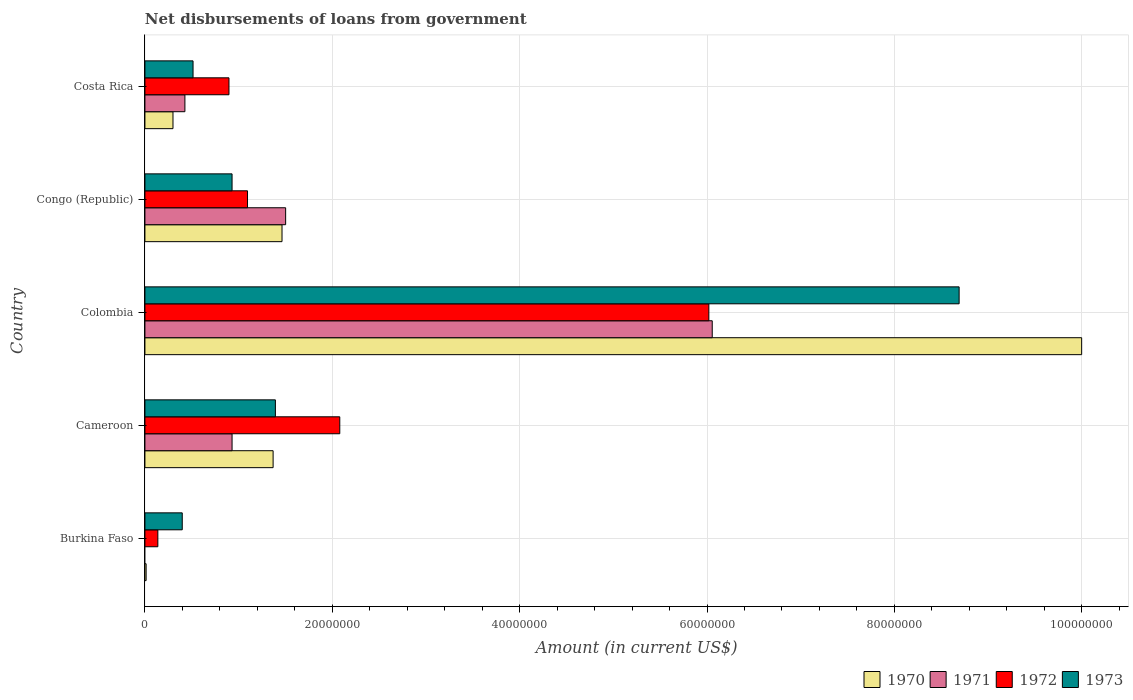How many different coloured bars are there?
Provide a short and direct response. 4. How many groups of bars are there?
Your response must be concise. 5. How many bars are there on the 1st tick from the top?
Your response must be concise. 4. How many bars are there on the 2nd tick from the bottom?
Offer a terse response. 4. In how many cases, is the number of bars for a given country not equal to the number of legend labels?
Offer a terse response. 1. What is the amount of loan disbursed from government in 1972 in Congo (Republic)?
Provide a short and direct response. 1.10e+07. Across all countries, what is the maximum amount of loan disbursed from government in 1973?
Offer a terse response. 8.69e+07. Across all countries, what is the minimum amount of loan disbursed from government in 1973?
Your answer should be very brief. 3.98e+06. In which country was the amount of loan disbursed from government in 1970 maximum?
Offer a terse response. Colombia. What is the total amount of loan disbursed from government in 1973 in the graph?
Your response must be concise. 1.19e+08. What is the difference between the amount of loan disbursed from government in 1973 in Cameroon and that in Costa Rica?
Your answer should be very brief. 8.79e+06. What is the difference between the amount of loan disbursed from government in 1972 in Congo (Republic) and the amount of loan disbursed from government in 1970 in Costa Rica?
Your answer should be compact. 7.96e+06. What is the average amount of loan disbursed from government in 1973 per country?
Your answer should be very brief. 2.39e+07. What is the difference between the amount of loan disbursed from government in 1973 and amount of loan disbursed from government in 1971 in Cameroon?
Your answer should be very brief. 4.63e+06. What is the ratio of the amount of loan disbursed from government in 1973 in Cameroon to that in Costa Rica?
Your response must be concise. 2.71. Is the amount of loan disbursed from government in 1972 in Burkina Faso less than that in Congo (Republic)?
Provide a succinct answer. Yes. Is the difference between the amount of loan disbursed from government in 1973 in Colombia and Congo (Republic) greater than the difference between the amount of loan disbursed from government in 1971 in Colombia and Congo (Republic)?
Your answer should be very brief. Yes. What is the difference between the highest and the second highest amount of loan disbursed from government in 1973?
Offer a terse response. 7.30e+07. What is the difference between the highest and the lowest amount of loan disbursed from government in 1972?
Your response must be concise. 5.88e+07. Is it the case that in every country, the sum of the amount of loan disbursed from government in 1970 and amount of loan disbursed from government in 1971 is greater than the sum of amount of loan disbursed from government in 1972 and amount of loan disbursed from government in 1973?
Provide a succinct answer. No. Is it the case that in every country, the sum of the amount of loan disbursed from government in 1972 and amount of loan disbursed from government in 1970 is greater than the amount of loan disbursed from government in 1971?
Provide a succinct answer. Yes. Are all the bars in the graph horizontal?
Your answer should be compact. Yes. How many countries are there in the graph?
Offer a very short reply. 5. Are the values on the major ticks of X-axis written in scientific E-notation?
Ensure brevity in your answer.  No. Does the graph contain any zero values?
Keep it short and to the point. Yes. How many legend labels are there?
Ensure brevity in your answer.  4. How are the legend labels stacked?
Provide a short and direct response. Horizontal. What is the title of the graph?
Your response must be concise. Net disbursements of loans from government. What is the label or title of the Y-axis?
Provide a short and direct response. Country. What is the Amount (in current US$) of 1970 in Burkina Faso?
Give a very brief answer. 1.29e+05. What is the Amount (in current US$) in 1972 in Burkina Faso?
Keep it short and to the point. 1.38e+06. What is the Amount (in current US$) of 1973 in Burkina Faso?
Your answer should be compact. 3.98e+06. What is the Amount (in current US$) of 1970 in Cameroon?
Provide a short and direct response. 1.37e+07. What is the Amount (in current US$) in 1971 in Cameroon?
Offer a very short reply. 9.30e+06. What is the Amount (in current US$) of 1972 in Cameroon?
Keep it short and to the point. 2.08e+07. What is the Amount (in current US$) of 1973 in Cameroon?
Provide a succinct answer. 1.39e+07. What is the Amount (in current US$) in 1970 in Colombia?
Give a very brief answer. 1.00e+08. What is the Amount (in current US$) in 1971 in Colombia?
Your answer should be very brief. 6.06e+07. What is the Amount (in current US$) of 1972 in Colombia?
Your answer should be very brief. 6.02e+07. What is the Amount (in current US$) of 1973 in Colombia?
Give a very brief answer. 8.69e+07. What is the Amount (in current US$) of 1970 in Congo (Republic)?
Give a very brief answer. 1.46e+07. What is the Amount (in current US$) of 1971 in Congo (Republic)?
Your answer should be very brief. 1.50e+07. What is the Amount (in current US$) in 1972 in Congo (Republic)?
Provide a short and direct response. 1.10e+07. What is the Amount (in current US$) in 1973 in Congo (Republic)?
Offer a very short reply. 9.30e+06. What is the Amount (in current US$) of 1970 in Costa Rica?
Ensure brevity in your answer.  3.00e+06. What is the Amount (in current US$) of 1971 in Costa Rica?
Offer a very short reply. 4.27e+06. What is the Amount (in current US$) of 1972 in Costa Rica?
Your response must be concise. 8.97e+06. What is the Amount (in current US$) in 1973 in Costa Rica?
Make the answer very short. 5.14e+06. Across all countries, what is the maximum Amount (in current US$) in 1970?
Ensure brevity in your answer.  1.00e+08. Across all countries, what is the maximum Amount (in current US$) of 1971?
Keep it short and to the point. 6.06e+07. Across all countries, what is the maximum Amount (in current US$) in 1972?
Provide a short and direct response. 6.02e+07. Across all countries, what is the maximum Amount (in current US$) in 1973?
Provide a short and direct response. 8.69e+07. Across all countries, what is the minimum Amount (in current US$) of 1970?
Offer a very short reply. 1.29e+05. Across all countries, what is the minimum Amount (in current US$) in 1971?
Ensure brevity in your answer.  0. Across all countries, what is the minimum Amount (in current US$) in 1972?
Make the answer very short. 1.38e+06. Across all countries, what is the minimum Amount (in current US$) of 1973?
Provide a short and direct response. 3.98e+06. What is the total Amount (in current US$) in 1970 in the graph?
Your response must be concise. 1.31e+08. What is the total Amount (in current US$) in 1971 in the graph?
Your response must be concise. 8.92e+07. What is the total Amount (in current US$) in 1972 in the graph?
Your response must be concise. 1.02e+08. What is the total Amount (in current US$) of 1973 in the graph?
Your response must be concise. 1.19e+08. What is the difference between the Amount (in current US$) of 1970 in Burkina Faso and that in Cameroon?
Your response must be concise. -1.36e+07. What is the difference between the Amount (in current US$) in 1972 in Burkina Faso and that in Cameroon?
Provide a short and direct response. -1.94e+07. What is the difference between the Amount (in current US$) in 1973 in Burkina Faso and that in Cameroon?
Provide a short and direct response. -9.94e+06. What is the difference between the Amount (in current US$) in 1970 in Burkina Faso and that in Colombia?
Offer a terse response. -9.99e+07. What is the difference between the Amount (in current US$) of 1972 in Burkina Faso and that in Colombia?
Keep it short and to the point. -5.88e+07. What is the difference between the Amount (in current US$) in 1973 in Burkina Faso and that in Colombia?
Offer a very short reply. -8.29e+07. What is the difference between the Amount (in current US$) in 1970 in Burkina Faso and that in Congo (Republic)?
Keep it short and to the point. -1.45e+07. What is the difference between the Amount (in current US$) in 1972 in Burkina Faso and that in Congo (Republic)?
Keep it short and to the point. -9.57e+06. What is the difference between the Amount (in current US$) of 1973 in Burkina Faso and that in Congo (Republic)?
Provide a succinct answer. -5.32e+06. What is the difference between the Amount (in current US$) of 1970 in Burkina Faso and that in Costa Rica?
Ensure brevity in your answer.  -2.87e+06. What is the difference between the Amount (in current US$) of 1972 in Burkina Faso and that in Costa Rica?
Your response must be concise. -7.59e+06. What is the difference between the Amount (in current US$) in 1973 in Burkina Faso and that in Costa Rica?
Offer a terse response. -1.15e+06. What is the difference between the Amount (in current US$) of 1970 in Cameroon and that in Colombia?
Your answer should be compact. -8.63e+07. What is the difference between the Amount (in current US$) in 1971 in Cameroon and that in Colombia?
Give a very brief answer. -5.13e+07. What is the difference between the Amount (in current US$) in 1972 in Cameroon and that in Colombia?
Your answer should be compact. -3.94e+07. What is the difference between the Amount (in current US$) in 1973 in Cameroon and that in Colombia?
Ensure brevity in your answer.  -7.30e+07. What is the difference between the Amount (in current US$) in 1970 in Cameroon and that in Congo (Republic)?
Offer a very short reply. -9.51e+05. What is the difference between the Amount (in current US$) in 1971 in Cameroon and that in Congo (Republic)?
Your response must be concise. -5.72e+06. What is the difference between the Amount (in current US$) of 1972 in Cameroon and that in Congo (Republic)?
Your response must be concise. 9.85e+06. What is the difference between the Amount (in current US$) of 1973 in Cameroon and that in Congo (Republic)?
Offer a very short reply. 4.63e+06. What is the difference between the Amount (in current US$) in 1970 in Cameroon and that in Costa Rica?
Keep it short and to the point. 1.07e+07. What is the difference between the Amount (in current US$) of 1971 in Cameroon and that in Costa Rica?
Make the answer very short. 5.03e+06. What is the difference between the Amount (in current US$) in 1972 in Cameroon and that in Costa Rica?
Offer a very short reply. 1.18e+07. What is the difference between the Amount (in current US$) in 1973 in Cameroon and that in Costa Rica?
Offer a very short reply. 8.79e+06. What is the difference between the Amount (in current US$) of 1970 in Colombia and that in Congo (Republic)?
Your answer should be very brief. 8.54e+07. What is the difference between the Amount (in current US$) of 1971 in Colombia and that in Congo (Republic)?
Make the answer very short. 4.55e+07. What is the difference between the Amount (in current US$) in 1972 in Colombia and that in Congo (Republic)?
Offer a very short reply. 4.92e+07. What is the difference between the Amount (in current US$) in 1973 in Colombia and that in Congo (Republic)?
Your answer should be very brief. 7.76e+07. What is the difference between the Amount (in current US$) in 1970 in Colombia and that in Costa Rica?
Ensure brevity in your answer.  9.70e+07. What is the difference between the Amount (in current US$) in 1971 in Colombia and that in Costa Rica?
Provide a short and direct response. 5.63e+07. What is the difference between the Amount (in current US$) of 1972 in Colombia and that in Costa Rica?
Keep it short and to the point. 5.12e+07. What is the difference between the Amount (in current US$) in 1973 in Colombia and that in Costa Rica?
Your answer should be compact. 8.18e+07. What is the difference between the Amount (in current US$) of 1970 in Congo (Republic) and that in Costa Rica?
Offer a terse response. 1.16e+07. What is the difference between the Amount (in current US$) in 1971 in Congo (Republic) and that in Costa Rica?
Your response must be concise. 1.08e+07. What is the difference between the Amount (in current US$) in 1972 in Congo (Republic) and that in Costa Rica?
Make the answer very short. 1.98e+06. What is the difference between the Amount (in current US$) of 1973 in Congo (Republic) and that in Costa Rica?
Keep it short and to the point. 4.16e+06. What is the difference between the Amount (in current US$) in 1970 in Burkina Faso and the Amount (in current US$) in 1971 in Cameroon?
Keep it short and to the point. -9.17e+06. What is the difference between the Amount (in current US$) of 1970 in Burkina Faso and the Amount (in current US$) of 1972 in Cameroon?
Keep it short and to the point. -2.07e+07. What is the difference between the Amount (in current US$) of 1970 in Burkina Faso and the Amount (in current US$) of 1973 in Cameroon?
Make the answer very short. -1.38e+07. What is the difference between the Amount (in current US$) of 1972 in Burkina Faso and the Amount (in current US$) of 1973 in Cameroon?
Provide a succinct answer. -1.25e+07. What is the difference between the Amount (in current US$) of 1970 in Burkina Faso and the Amount (in current US$) of 1971 in Colombia?
Offer a terse response. -6.04e+07. What is the difference between the Amount (in current US$) of 1970 in Burkina Faso and the Amount (in current US$) of 1972 in Colombia?
Ensure brevity in your answer.  -6.01e+07. What is the difference between the Amount (in current US$) of 1970 in Burkina Faso and the Amount (in current US$) of 1973 in Colombia?
Offer a terse response. -8.68e+07. What is the difference between the Amount (in current US$) in 1972 in Burkina Faso and the Amount (in current US$) in 1973 in Colombia?
Your answer should be very brief. -8.55e+07. What is the difference between the Amount (in current US$) in 1970 in Burkina Faso and the Amount (in current US$) in 1971 in Congo (Republic)?
Your answer should be compact. -1.49e+07. What is the difference between the Amount (in current US$) in 1970 in Burkina Faso and the Amount (in current US$) in 1972 in Congo (Republic)?
Your answer should be compact. -1.08e+07. What is the difference between the Amount (in current US$) in 1970 in Burkina Faso and the Amount (in current US$) in 1973 in Congo (Republic)?
Give a very brief answer. -9.17e+06. What is the difference between the Amount (in current US$) in 1972 in Burkina Faso and the Amount (in current US$) in 1973 in Congo (Republic)?
Provide a short and direct response. -7.92e+06. What is the difference between the Amount (in current US$) in 1970 in Burkina Faso and the Amount (in current US$) in 1971 in Costa Rica?
Offer a very short reply. -4.14e+06. What is the difference between the Amount (in current US$) in 1970 in Burkina Faso and the Amount (in current US$) in 1972 in Costa Rica?
Provide a succinct answer. -8.84e+06. What is the difference between the Amount (in current US$) of 1970 in Burkina Faso and the Amount (in current US$) of 1973 in Costa Rica?
Offer a very short reply. -5.01e+06. What is the difference between the Amount (in current US$) of 1972 in Burkina Faso and the Amount (in current US$) of 1973 in Costa Rica?
Ensure brevity in your answer.  -3.76e+06. What is the difference between the Amount (in current US$) in 1970 in Cameroon and the Amount (in current US$) in 1971 in Colombia?
Give a very brief answer. -4.69e+07. What is the difference between the Amount (in current US$) of 1970 in Cameroon and the Amount (in current US$) of 1972 in Colombia?
Your answer should be compact. -4.65e+07. What is the difference between the Amount (in current US$) in 1970 in Cameroon and the Amount (in current US$) in 1973 in Colombia?
Keep it short and to the point. -7.32e+07. What is the difference between the Amount (in current US$) in 1971 in Cameroon and the Amount (in current US$) in 1972 in Colombia?
Ensure brevity in your answer.  -5.09e+07. What is the difference between the Amount (in current US$) in 1971 in Cameroon and the Amount (in current US$) in 1973 in Colombia?
Offer a very short reply. -7.76e+07. What is the difference between the Amount (in current US$) of 1972 in Cameroon and the Amount (in current US$) of 1973 in Colombia?
Offer a very short reply. -6.61e+07. What is the difference between the Amount (in current US$) in 1970 in Cameroon and the Amount (in current US$) in 1971 in Congo (Republic)?
Provide a short and direct response. -1.34e+06. What is the difference between the Amount (in current US$) of 1970 in Cameroon and the Amount (in current US$) of 1972 in Congo (Republic)?
Make the answer very short. 2.73e+06. What is the difference between the Amount (in current US$) of 1970 in Cameroon and the Amount (in current US$) of 1973 in Congo (Republic)?
Your answer should be very brief. 4.38e+06. What is the difference between the Amount (in current US$) in 1971 in Cameroon and the Amount (in current US$) in 1972 in Congo (Republic)?
Make the answer very short. -1.65e+06. What is the difference between the Amount (in current US$) of 1971 in Cameroon and the Amount (in current US$) of 1973 in Congo (Republic)?
Make the answer very short. 0. What is the difference between the Amount (in current US$) in 1972 in Cameroon and the Amount (in current US$) in 1973 in Congo (Republic)?
Keep it short and to the point. 1.15e+07. What is the difference between the Amount (in current US$) of 1970 in Cameroon and the Amount (in current US$) of 1971 in Costa Rica?
Offer a terse response. 9.41e+06. What is the difference between the Amount (in current US$) of 1970 in Cameroon and the Amount (in current US$) of 1972 in Costa Rica?
Provide a succinct answer. 4.71e+06. What is the difference between the Amount (in current US$) of 1970 in Cameroon and the Amount (in current US$) of 1973 in Costa Rica?
Keep it short and to the point. 8.55e+06. What is the difference between the Amount (in current US$) of 1971 in Cameroon and the Amount (in current US$) of 1972 in Costa Rica?
Offer a terse response. 3.30e+05. What is the difference between the Amount (in current US$) of 1971 in Cameroon and the Amount (in current US$) of 1973 in Costa Rica?
Give a very brief answer. 4.16e+06. What is the difference between the Amount (in current US$) of 1972 in Cameroon and the Amount (in current US$) of 1973 in Costa Rica?
Make the answer very short. 1.57e+07. What is the difference between the Amount (in current US$) of 1970 in Colombia and the Amount (in current US$) of 1971 in Congo (Republic)?
Make the answer very short. 8.50e+07. What is the difference between the Amount (in current US$) in 1970 in Colombia and the Amount (in current US$) in 1972 in Congo (Republic)?
Offer a very short reply. 8.90e+07. What is the difference between the Amount (in current US$) of 1970 in Colombia and the Amount (in current US$) of 1973 in Congo (Republic)?
Give a very brief answer. 9.07e+07. What is the difference between the Amount (in current US$) in 1971 in Colombia and the Amount (in current US$) in 1972 in Congo (Republic)?
Your answer should be very brief. 4.96e+07. What is the difference between the Amount (in current US$) of 1971 in Colombia and the Amount (in current US$) of 1973 in Congo (Republic)?
Your answer should be compact. 5.13e+07. What is the difference between the Amount (in current US$) of 1972 in Colombia and the Amount (in current US$) of 1973 in Congo (Republic)?
Keep it short and to the point. 5.09e+07. What is the difference between the Amount (in current US$) in 1970 in Colombia and the Amount (in current US$) in 1971 in Costa Rica?
Ensure brevity in your answer.  9.57e+07. What is the difference between the Amount (in current US$) in 1970 in Colombia and the Amount (in current US$) in 1972 in Costa Rica?
Your answer should be compact. 9.10e+07. What is the difference between the Amount (in current US$) in 1970 in Colombia and the Amount (in current US$) in 1973 in Costa Rica?
Provide a short and direct response. 9.49e+07. What is the difference between the Amount (in current US$) in 1971 in Colombia and the Amount (in current US$) in 1972 in Costa Rica?
Offer a very short reply. 5.16e+07. What is the difference between the Amount (in current US$) of 1971 in Colombia and the Amount (in current US$) of 1973 in Costa Rica?
Your answer should be compact. 5.54e+07. What is the difference between the Amount (in current US$) in 1972 in Colombia and the Amount (in current US$) in 1973 in Costa Rica?
Offer a very short reply. 5.51e+07. What is the difference between the Amount (in current US$) in 1970 in Congo (Republic) and the Amount (in current US$) in 1971 in Costa Rica?
Make the answer very short. 1.04e+07. What is the difference between the Amount (in current US$) of 1970 in Congo (Republic) and the Amount (in current US$) of 1972 in Costa Rica?
Your response must be concise. 5.66e+06. What is the difference between the Amount (in current US$) in 1970 in Congo (Republic) and the Amount (in current US$) in 1973 in Costa Rica?
Ensure brevity in your answer.  9.50e+06. What is the difference between the Amount (in current US$) of 1971 in Congo (Republic) and the Amount (in current US$) of 1972 in Costa Rica?
Provide a succinct answer. 6.05e+06. What is the difference between the Amount (in current US$) in 1971 in Congo (Republic) and the Amount (in current US$) in 1973 in Costa Rica?
Keep it short and to the point. 9.88e+06. What is the difference between the Amount (in current US$) in 1972 in Congo (Republic) and the Amount (in current US$) in 1973 in Costa Rica?
Provide a succinct answer. 5.81e+06. What is the average Amount (in current US$) of 1970 per country?
Make the answer very short. 2.63e+07. What is the average Amount (in current US$) in 1971 per country?
Offer a terse response. 1.78e+07. What is the average Amount (in current US$) in 1972 per country?
Provide a short and direct response. 2.05e+07. What is the average Amount (in current US$) in 1973 per country?
Your response must be concise. 2.39e+07. What is the difference between the Amount (in current US$) in 1970 and Amount (in current US$) in 1972 in Burkina Faso?
Give a very brief answer. -1.25e+06. What is the difference between the Amount (in current US$) in 1970 and Amount (in current US$) in 1973 in Burkina Faso?
Provide a short and direct response. -3.86e+06. What is the difference between the Amount (in current US$) in 1972 and Amount (in current US$) in 1973 in Burkina Faso?
Give a very brief answer. -2.60e+06. What is the difference between the Amount (in current US$) of 1970 and Amount (in current US$) of 1971 in Cameroon?
Your answer should be compact. 4.38e+06. What is the difference between the Amount (in current US$) in 1970 and Amount (in current US$) in 1972 in Cameroon?
Give a very brief answer. -7.12e+06. What is the difference between the Amount (in current US$) in 1970 and Amount (in current US$) in 1973 in Cameroon?
Make the answer very short. -2.45e+05. What is the difference between the Amount (in current US$) in 1971 and Amount (in current US$) in 1972 in Cameroon?
Offer a terse response. -1.15e+07. What is the difference between the Amount (in current US$) in 1971 and Amount (in current US$) in 1973 in Cameroon?
Provide a succinct answer. -4.63e+06. What is the difference between the Amount (in current US$) of 1972 and Amount (in current US$) of 1973 in Cameroon?
Keep it short and to the point. 6.87e+06. What is the difference between the Amount (in current US$) of 1970 and Amount (in current US$) of 1971 in Colombia?
Your response must be concise. 3.94e+07. What is the difference between the Amount (in current US$) in 1970 and Amount (in current US$) in 1972 in Colombia?
Provide a short and direct response. 3.98e+07. What is the difference between the Amount (in current US$) in 1970 and Amount (in current US$) in 1973 in Colombia?
Your answer should be compact. 1.31e+07. What is the difference between the Amount (in current US$) of 1971 and Amount (in current US$) of 1972 in Colombia?
Keep it short and to the point. 3.62e+05. What is the difference between the Amount (in current US$) of 1971 and Amount (in current US$) of 1973 in Colombia?
Provide a short and direct response. -2.64e+07. What is the difference between the Amount (in current US$) of 1972 and Amount (in current US$) of 1973 in Colombia?
Give a very brief answer. -2.67e+07. What is the difference between the Amount (in current US$) of 1970 and Amount (in current US$) of 1971 in Congo (Republic)?
Offer a terse response. -3.88e+05. What is the difference between the Amount (in current US$) of 1970 and Amount (in current US$) of 1972 in Congo (Republic)?
Offer a very short reply. 3.68e+06. What is the difference between the Amount (in current US$) of 1970 and Amount (in current US$) of 1973 in Congo (Republic)?
Offer a very short reply. 5.33e+06. What is the difference between the Amount (in current US$) in 1971 and Amount (in current US$) in 1972 in Congo (Republic)?
Give a very brief answer. 4.07e+06. What is the difference between the Amount (in current US$) of 1971 and Amount (in current US$) of 1973 in Congo (Republic)?
Your answer should be compact. 5.72e+06. What is the difference between the Amount (in current US$) of 1972 and Amount (in current US$) of 1973 in Congo (Republic)?
Provide a short and direct response. 1.65e+06. What is the difference between the Amount (in current US$) in 1970 and Amount (in current US$) in 1971 in Costa Rica?
Offer a very short reply. -1.27e+06. What is the difference between the Amount (in current US$) of 1970 and Amount (in current US$) of 1972 in Costa Rica?
Provide a short and direct response. -5.98e+06. What is the difference between the Amount (in current US$) of 1970 and Amount (in current US$) of 1973 in Costa Rica?
Make the answer very short. -2.14e+06. What is the difference between the Amount (in current US$) in 1971 and Amount (in current US$) in 1972 in Costa Rica?
Provide a succinct answer. -4.70e+06. What is the difference between the Amount (in current US$) of 1971 and Amount (in current US$) of 1973 in Costa Rica?
Keep it short and to the point. -8.68e+05. What is the difference between the Amount (in current US$) in 1972 and Amount (in current US$) in 1973 in Costa Rica?
Keep it short and to the point. 3.84e+06. What is the ratio of the Amount (in current US$) in 1970 in Burkina Faso to that in Cameroon?
Your answer should be compact. 0.01. What is the ratio of the Amount (in current US$) in 1972 in Burkina Faso to that in Cameroon?
Keep it short and to the point. 0.07. What is the ratio of the Amount (in current US$) of 1973 in Burkina Faso to that in Cameroon?
Ensure brevity in your answer.  0.29. What is the ratio of the Amount (in current US$) of 1970 in Burkina Faso to that in Colombia?
Keep it short and to the point. 0. What is the ratio of the Amount (in current US$) in 1972 in Burkina Faso to that in Colombia?
Offer a very short reply. 0.02. What is the ratio of the Amount (in current US$) of 1973 in Burkina Faso to that in Colombia?
Ensure brevity in your answer.  0.05. What is the ratio of the Amount (in current US$) of 1970 in Burkina Faso to that in Congo (Republic)?
Your response must be concise. 0.01. What is the ratio of the Amount (in current US$) of 1972 in Burkina Faso to that in Congo (Republic)?
Offer a very short reply. 0.13. What is the ratio of the Amount (in current US$) in 1973 in Burkina Faso to that in Congo (Republic)?
Offer a very short reply. 0.43. What is the ratio of the Amount (in current US$) in 1970 in Burkina Faso to that in Costa Rica?
Make the answer very short. 0.04. What is the ratio of the Amount (in current US$) of 1972 in Burkina Faso to that in Costa Rica?
Offer a very short reply. 0.15. What is the ratio of the Amount (in current US$) in 1973 in Burkina Faso to that in Costa Rica?
Provide a succinct answer. 0.78. What is the ratio of the Amount (in current US$) of 1970 in Cameroon to that in Colombia?
Keep it short and to the point. 0.14. What is the ratio of the Amount (in current US$) of 1971 in Cameroon to that in Colombia?
Provide a succinct answer. 0.15. What is the ratio of the Amount (in current US$) of 1972 in Cameroon to that in Colombia?
Your answer should be compact. 0.35. What is the ratio of the Amount (in current US$) of 1973 in Cameroon to that in Colombia?
Provide a succinct answer. 0.16. What is the ratio of the Amount (in current US$) of 1970 in Cameroon to that in Congo (Republic)?
Your answer should be very brief. 0.94. What is the ratio of the Amount (in current US$) in 1971 in Cameroon to that in Congo (Republic)?
Offer a very short reply. 0.62. What is the ratio of the Amount (in current US$) in 1972 in Cameroon to that in Congo (Republic)?
Make the answer very short. 1.9. What is the ratio of the Amount (in current US$) of 1973 in Cameroon to that in Congo (Republic)?
Your answer should be compact. 1.5. What is the ratio of the Amount (in current US$) in 1970 in Cameroon to that in Costa Rica?
Keep it short and to the point. 4.57. What is the ratio of the Amount (in current US$) in 1971 in Cameroon to that in Costa Rica?
Provide a short and direct response. 2.18. What is the ratio of the Amount (in current US$) in 1972 in Cameroon to that in Costa Rica?
Provide a short and direct response. 2.32. What is the ratio of the Amount (in current US$) of 1973 in Cameroon to that in Costa Rica?
Offer a terse response. 2.71. What is the ratio of the Amount (in current US$) in 1970 in Colombia to that in Congo (Republic)?
Make the answer very short. 6.83. What is the ratio of the Amount (in current US$) of 1971 in Colombia to that in Congo (Republic)?
Ensure brevity in your answer.  4.03. What is the ratio of the Amount (in current US$) in 1972 in Colombia to that in Congo (Republic)?
Your answer should be compact. 5.5. What is the ratio of the Amount (in current US$) of 1973 in Colombia to that in Congo (Republic)?
Provide a short and direct response. 9.34. What is the ratio of the Amount (in current US$) in 1970 in Colombia to that in Costa Rica?
Provide a short and direct response. 33.38. What is the ratio of the Amount (in current US$) in 1971 in Colombia to that in Costa Rica?
Your answer should be very brief. 14.19. What is the ratio of the Amount (in current US$) in 1972 in Colombia to that in Costa Rica?
Give a very brief answer. 6.71. What is the ratio of the Amount (in current US$) in 1973 in Colombia to that in Costa Rica?
Your answer should be very brief. 16.92. What is the ratio of the Amount (in current US$) of 1970 in Congo (Republic) to that in Costa Rica?
Offer a very short reply. 4.88. What is the ratio of the Amount (in current US$) of 1971 in Congo (Republic) to that in Costa Rica?
Offer a very short reply. 3.52. What is the ratio of the Amount (in current US$) in 1972 in Congo (Republic) to that in Costa Rica?
Give a very brief answer. 1.22. What is the ratio of the Amount (in current US$) of 1973 in Congo (Republic) to that in Costa Rica?
Keep it short and to the point. 1.81. What is the difference between the highest and the second highest Amount (in current US$) of 1970?
Make the answer very short. 8.54e+07. What is the difference between the highest and the second highest Amount (in current US$) of 1971?
Ensure brevity in your answer.  4.55e+07. What is the difference between the highest and the second highest Amount (in current US$) of 1972?
Ensure brevity in your answer.  3.94e+07. What is the difference between the highest and the second highest Amount (in current US$) of 1973?
Provide a succinct answer. 7.30e+07. What is the difference between the highest and the lowest Amount (in current US$) of 1970?
Keep it short and to the point. 9.99e+07. What is the difference between the highest and the lowest Amount (in current US$) in 1971?
Ensure brevity in your answer.  6.06e+07. What is the difference between the highest and the lowest Amount (in current US$) in 1972?
Make the answer very short. 5.88e+07. What is the difference between the highest and the lowest Amount (in current US$) of 1973?
Provide a succinct answer. 8.29e+07. 